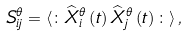Convert formula to latex. <formula><loc_0><loc_0><loc_500><loc_500>S _ { i j } ^ { \theta } = \langle \colon \widehat { X } _ { i } ^ { \theta } \left ( t \right ) \widehat { X } _ { j } ^ { \theta } \left ( t \right ) \colon \rangle \, ,</formula> 